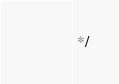<code> <loc_0><loc_0><loc_500><loc_500><_JavaScript_> */</code> 